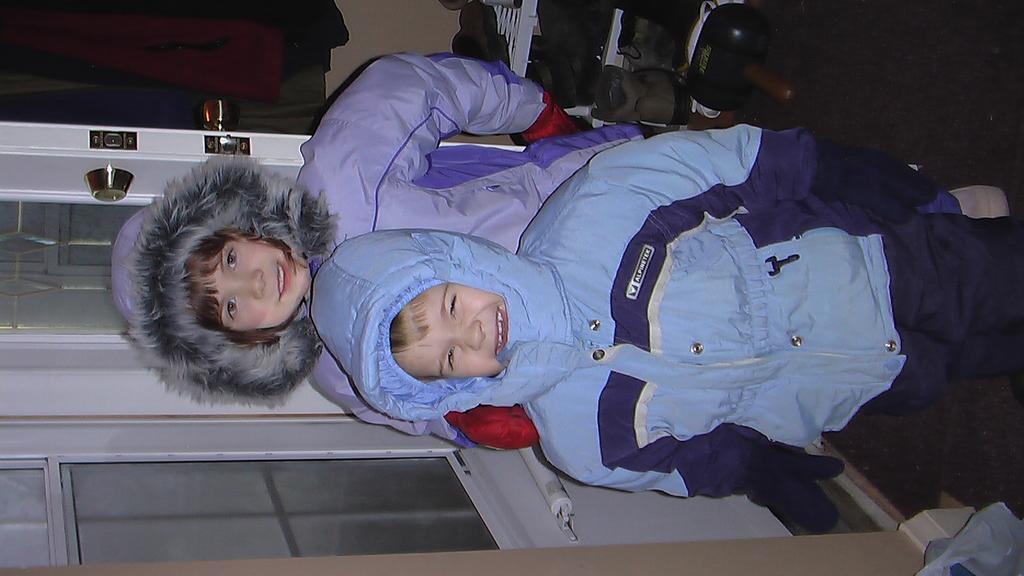Could you give a brief overview of what you see in this image? In this image I can see two persons standing, the person in front wearing blue jacket, and the person at back wearing purple color jacket. Background I can see the shoes in the rack and the doors are in white color. 